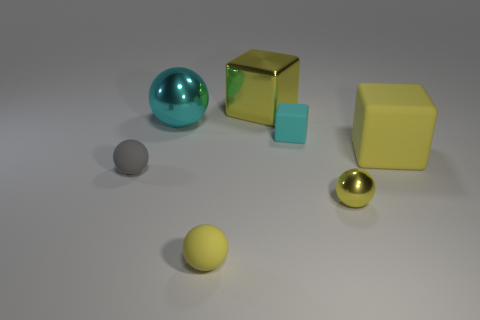What number of small objects are either cyan rubber blocks or yellow spheres?
Provide a succinct answer. 3. There is a gray matte thing; how many tiny rubber objects are behind it?
Give a very brief answer. 1. There is a large metal object that is the same shape as the tiny yellow metal object; what is its color?
Offer a terse response. Cyan. How many matte things are yellow things or purple cylinders?
Your answer should be compact. 2. There is a cyan object that is behind the tiny rubber object that is right of the yellow rubber sphere; is there a big yellow thing that is in front of it?
Make the answer very short. Yes. What is the color of the big sphere?
Offer a terse response. Cyan. Does the big metallic object that is right of the cyan ball have the same shape as the tiny cyan rubber object?
Your answer should be compact. Yes. What number of objects are small cyan things or metal things to the right of the small yellow rubber sphere?
Keep it short and to the point. 3. Does the big yellow thing that is left of the large yellow matte thing have the same material as the big cyan object?
Give a very brief answer. Yes. Is there anything else that has the same size as the cyan cube?
Provide a short and direct response. Yes. 